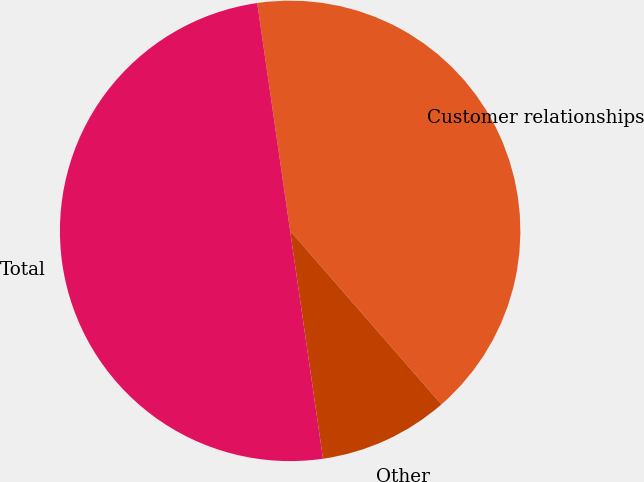Convert chart to OTSL. <chart><loc_0><loc_0><loc_500><loc_500><pie_chart><fcel>Customer relationships<fcel>Other<fcel>Total<nl><fcel>40.87%<fcel>9.13%<fcel>50.0%<nl></chart> 